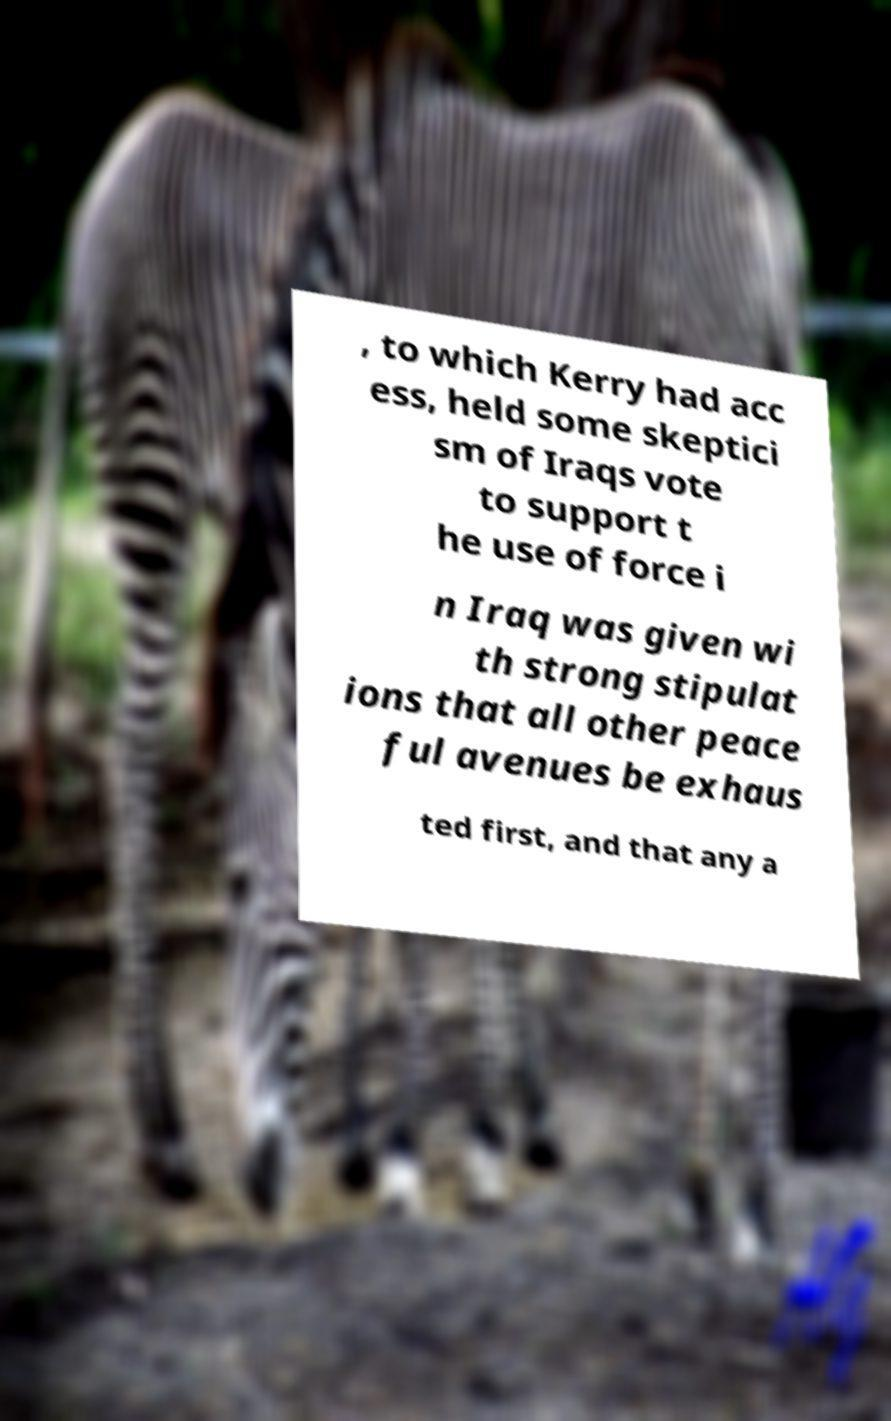What messages or text are displayed in this image? I need them in a readable, typed format. , to which Kerry had acc ess, held some skeptici sm of Iraqs vote to support t he use of force i n Iraq was given wi th strong stipulat ions that all other peace ful avenues be exhaus ted first, and that any a 